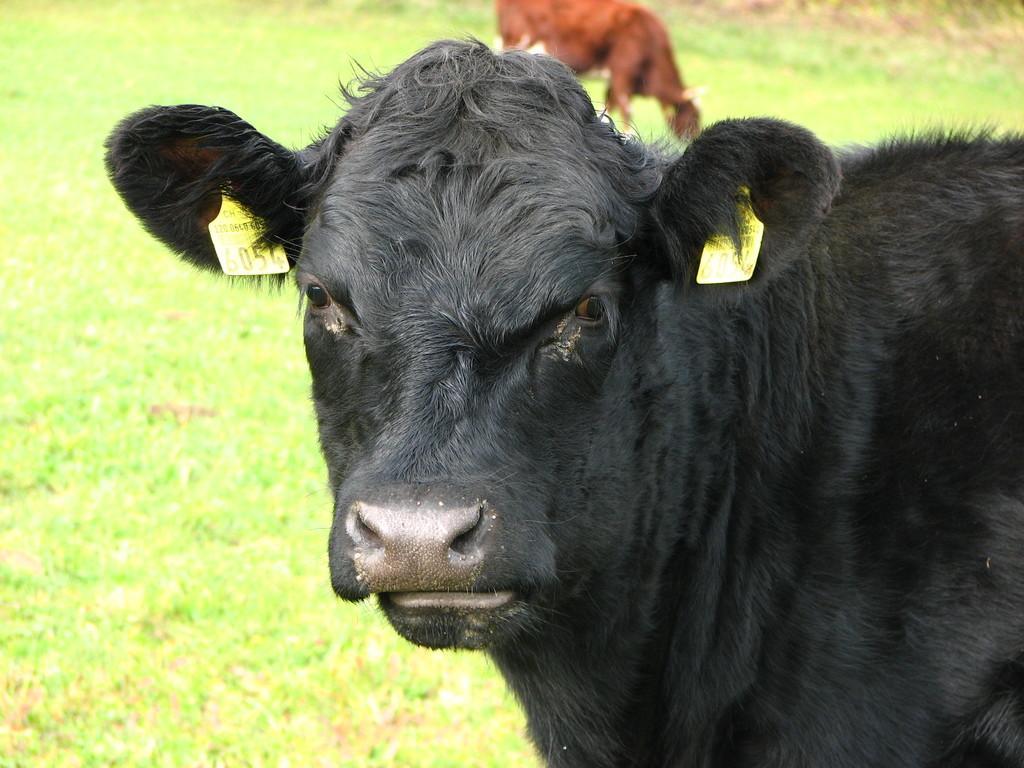Please provide a concise description of this image. In this picture I can see animals on the right side and in the background. I can see green grass. 